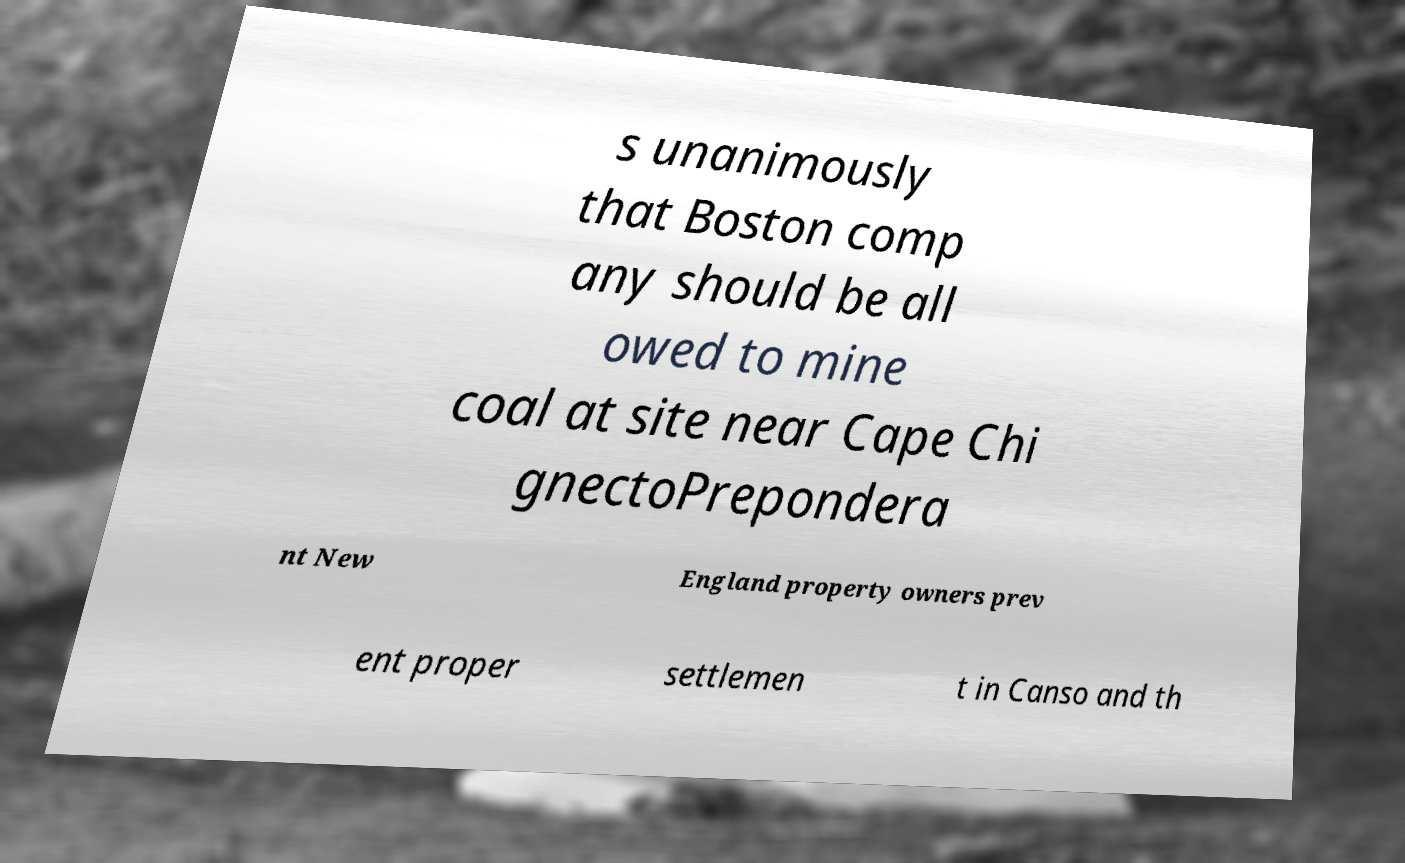Could you assist in decoding the text presented in this image and type it out clearly? s unanimously that Boston comp any should be all owed to mine coal at site near Cape Chi gnectoPrepondera nt New England property owners prev ent proper settlemen t in Canso and th 